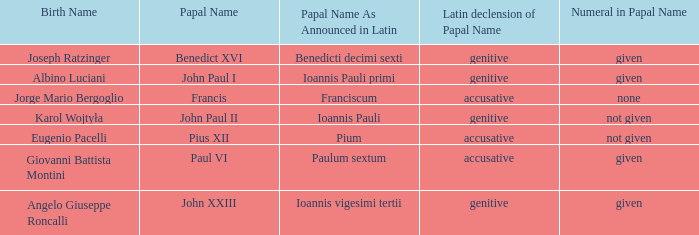For the pope born Eugenio Pacelli, what is the declension of his papal name? Accusative. 